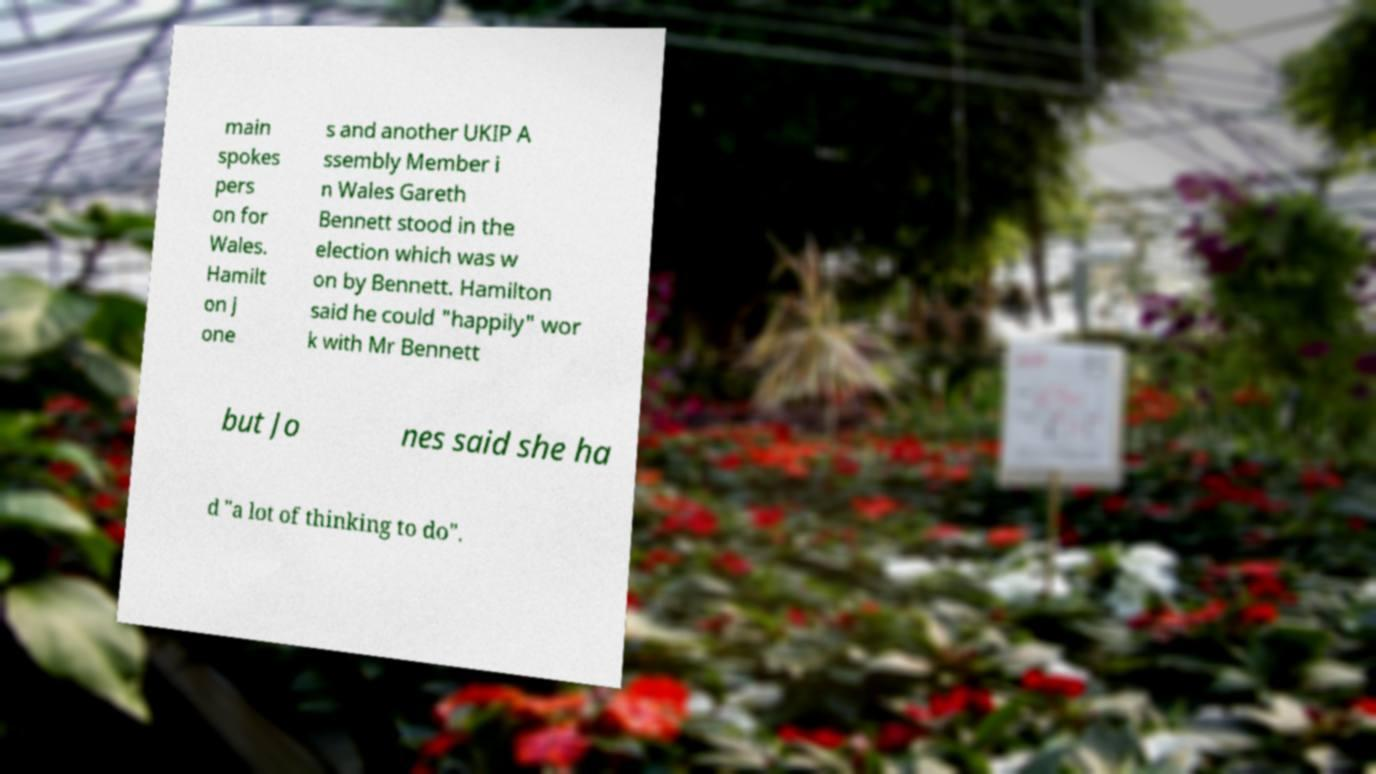Could you extract and type out the text from this image? main spokes pers on for Wales. Hamilt on J one s and another UKIP A ssembly Member i n Wales Gareth Bennett stood in the election which was w on by Bennett. Hamilton said he could "happily" wor k with Mr Bennett but Jo nes said she ha d "a lot of thinking to do". 